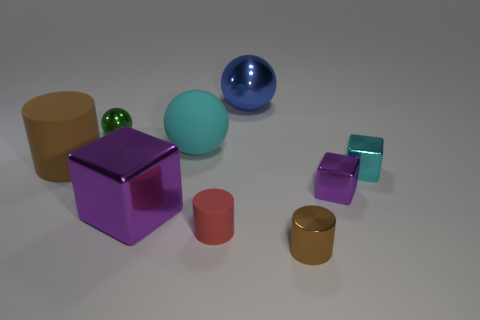What might be the purpose of these objects? The objects seem like they could be part of a 3D rendering or a modeling software test scene. They can be used to demonstrate lighting, shadow casting, reflections, and textures. Their simplicity in shape can also make them ideal for educational purposes, to teach about geometry and spatial relationships. 